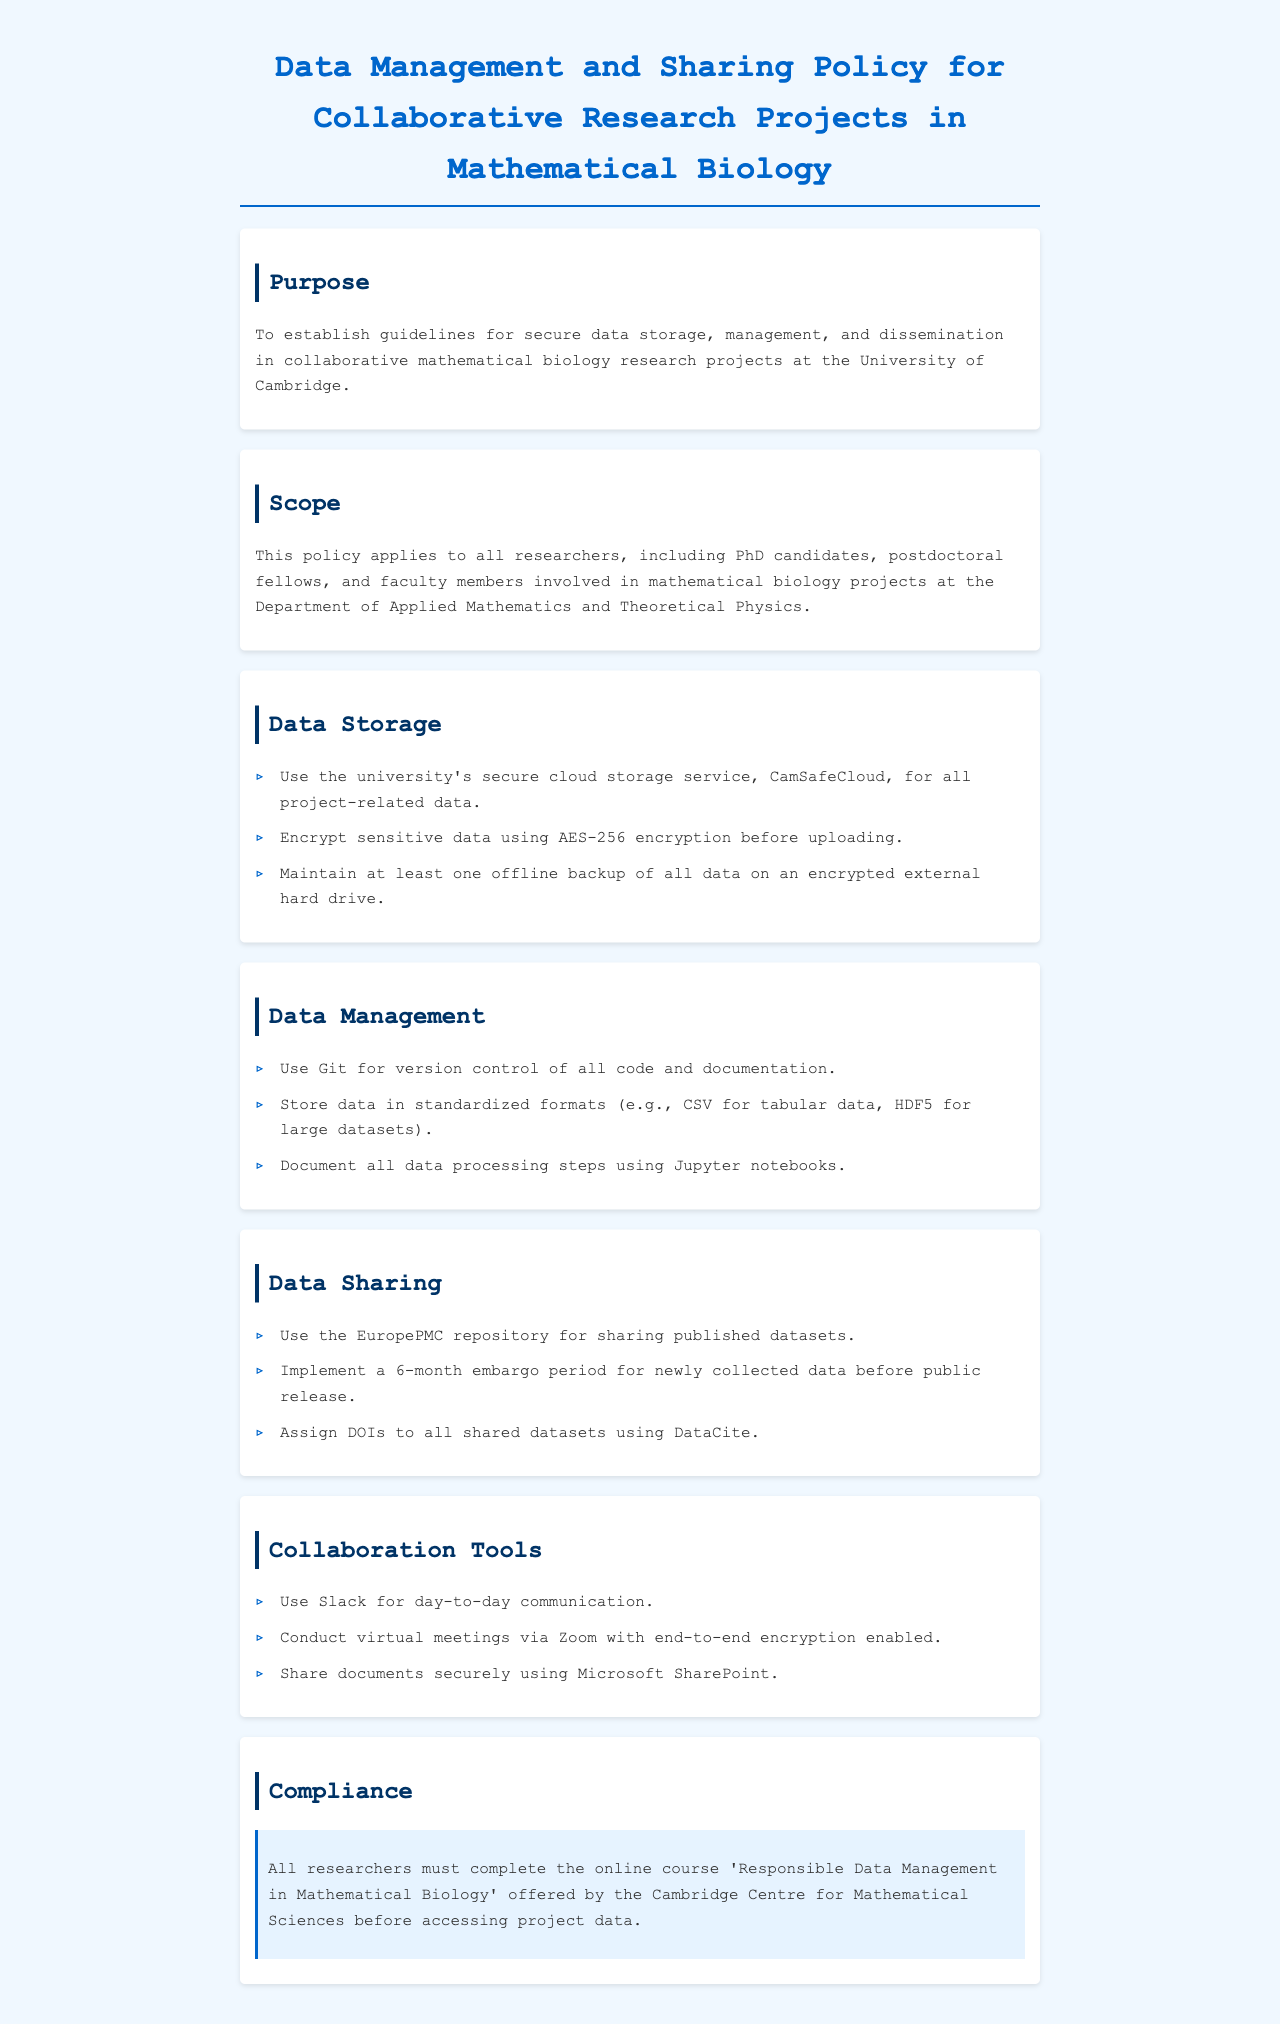What is the purpose of the policy? The purpose is stated in the "Purpose" section, which establishes guidelines for secure data storage, management, and dissemination.
Answer: Guidelines for secure data storage, management, and dissemination Who must complete the online course for compliance? The compliance section specifies that all researchers must complete the course, including PhD candidates, postdoctoral fellows, and faculty members.
Answer: All researchers What encryption method is required for sensitive data? The "Data Storage" section mentions AES-256 encryption specifically for sensitive data.
Answer: AES-256 How long is the embargo period for newly collected data? According to the "Data Sharing" section, the embargo period before public release is specified to be six months.
Answer: 6 months Which tool is recommended for version control? The "Data Management" section explicitly states the use of Git for version control.
Answer: Git Where should datasets be shared after publication? The "Data Sharing" section indicates EuropePMC as the repository for sharing published datasets.
Answer: EuropePMC What is the university's secure cloud storage service called? The "Data Storage" section names CamSafeCloud as the secure cloud storage service.
Answer: CamSafeCloud What documentation method is suggested for data processing steps? The "Data Management" section advises documenting all steps using Jupyter notebooks.
Answer: Jupyter notebooks In which department does this policy apply? The "Scope" section specifies the Department of Applied Mathematics and Theoretical Physics.
Answer: Department of Applied Mathematics and Theoretical Physics 